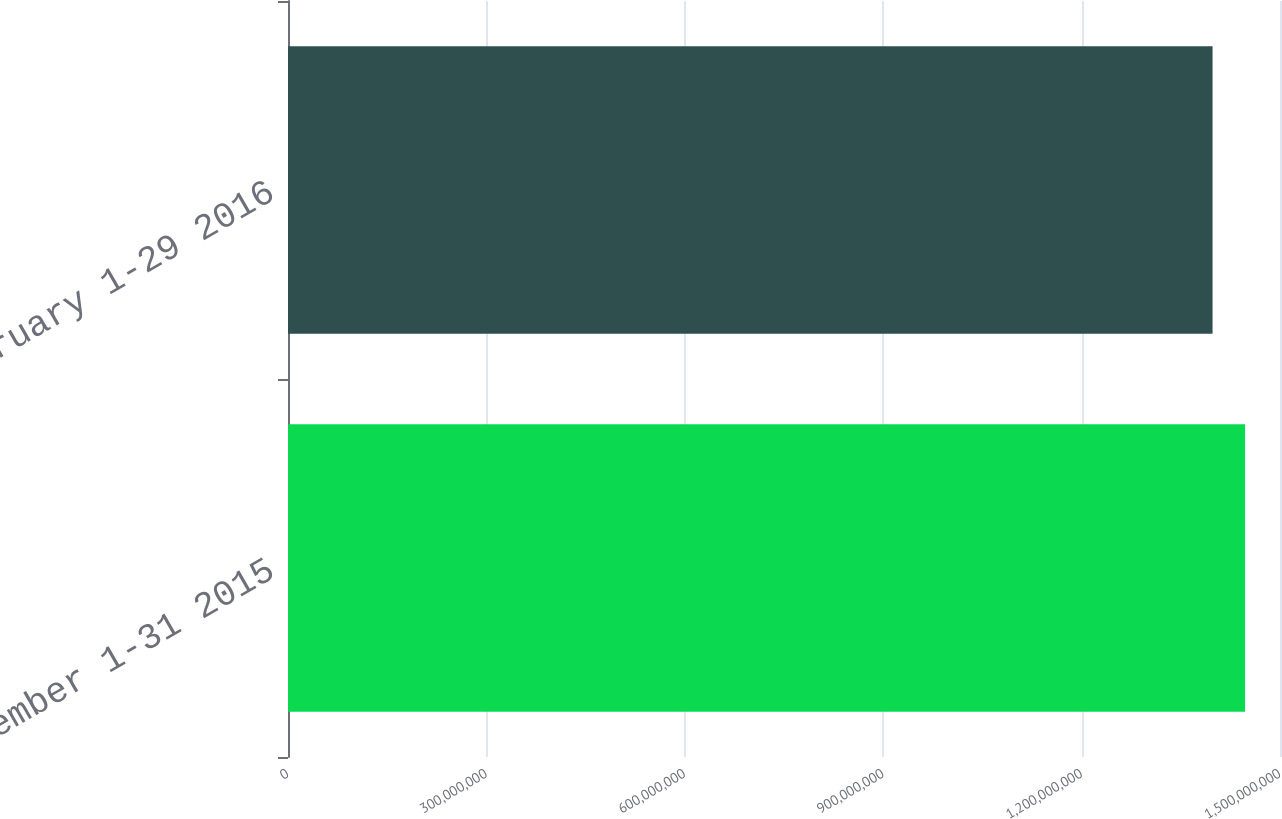<chart> <loc_0><loc_0><loc_500><loc_500><bar_chart><fcel>December 1-31 2015<fcel>February 1-29 2016<nl><fcel>1.44715e+09<fcel>1.39802e+09<nl></chart> 